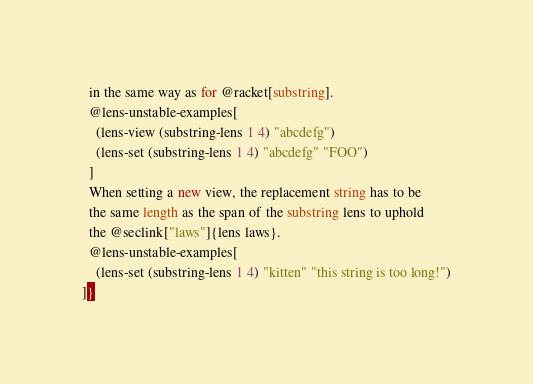Convert code to text. <code><loc_0><loc_0><loc_500><loc_500><_Racket_>  in the same way as for @racket[substring].
  @lens-unstable-examples[
    (lens-view (substring-lens 1 4) "abcdefg")
    (lens-set (substring-lens 1 4) "abcdefg" "FOO")
  ]
  When setting a new view, the replacement string has to be
  the same length as the span of the substring lens to uphold
  the @seclink["laws"]{lens laws}.
  @lens-unstable-examples[
    (lens-set (substring-lens 1 4) "kitten" "this string is too long!")
]}</code> 